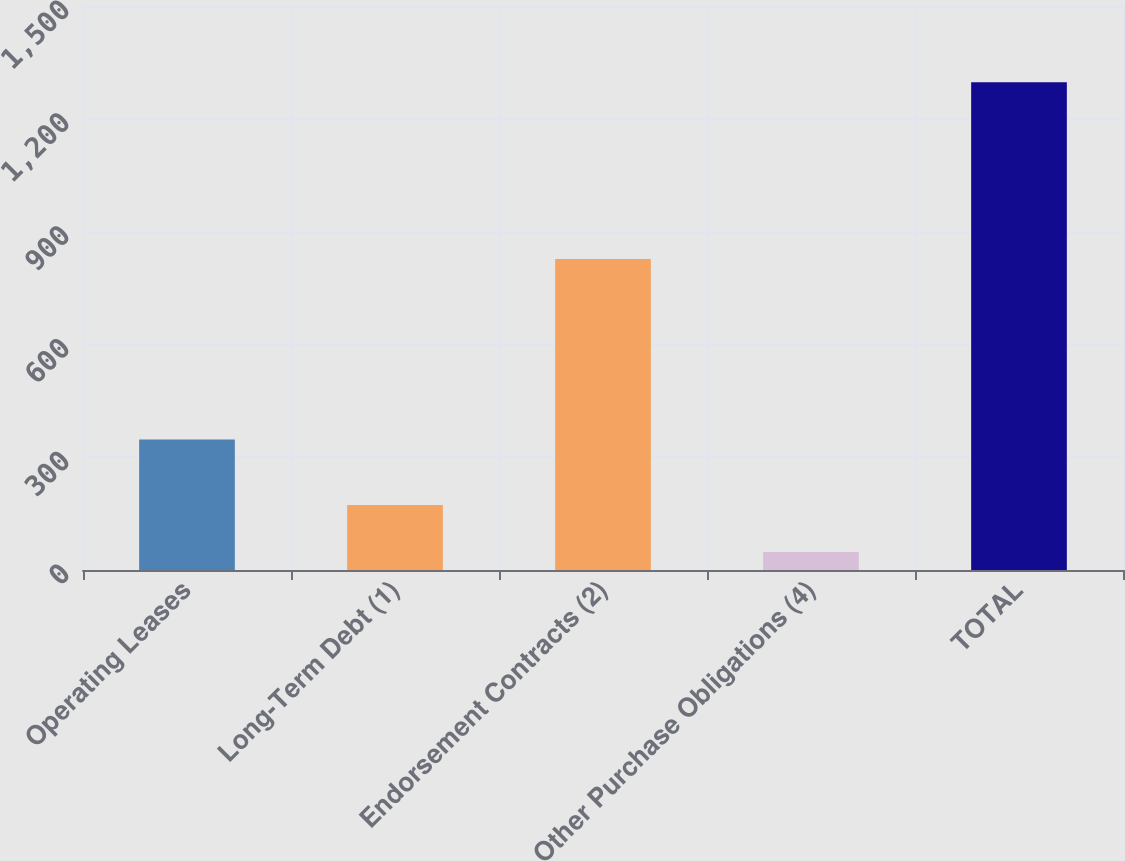Convert chart to OTSL. <chart><loc_0><loc_0><loc_500><loc_500><bar_chart><fcel>Operating Leases<fcel>Long-Term Debt (1)<fcel>Endorsement Contracts (2)<fcel>Other Purchase Obligations (4)<fcel>TOTAL<nl><fcel>347<fcel>172.9<fcel>827<fcel>48<fcel>1297<nl></chart> 